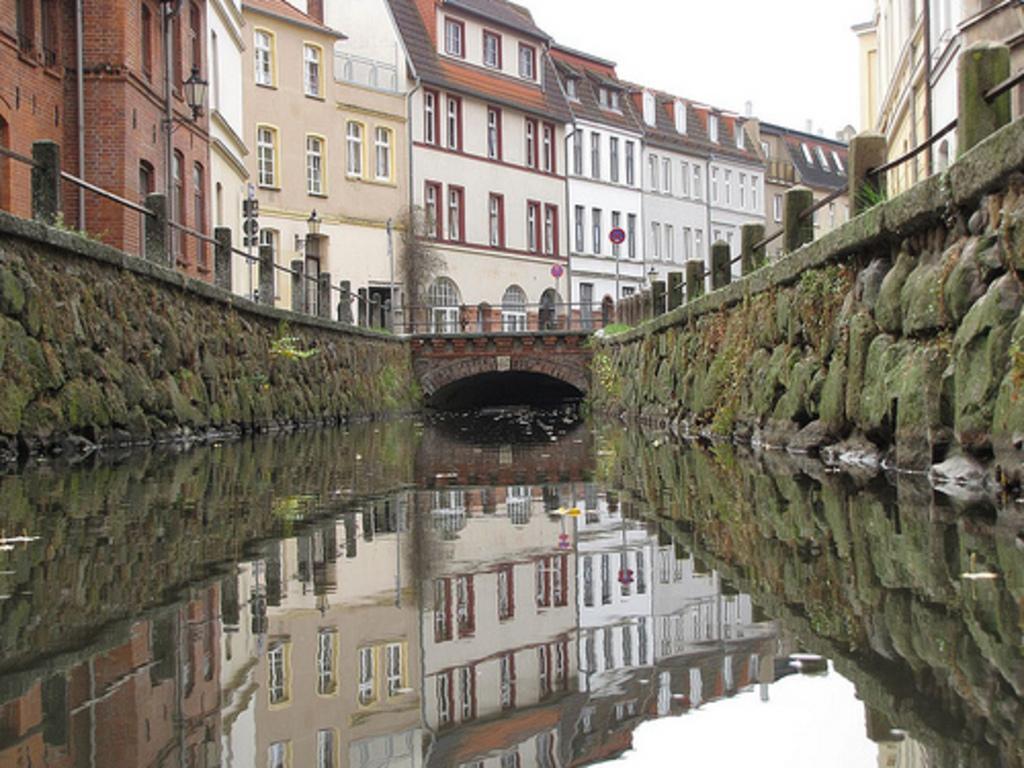Can you describe this image briefly? In this image there is a bridge. There is water. There are rock walls on the both sides. There are buildings. There is tree near the bridge. There is sky. 